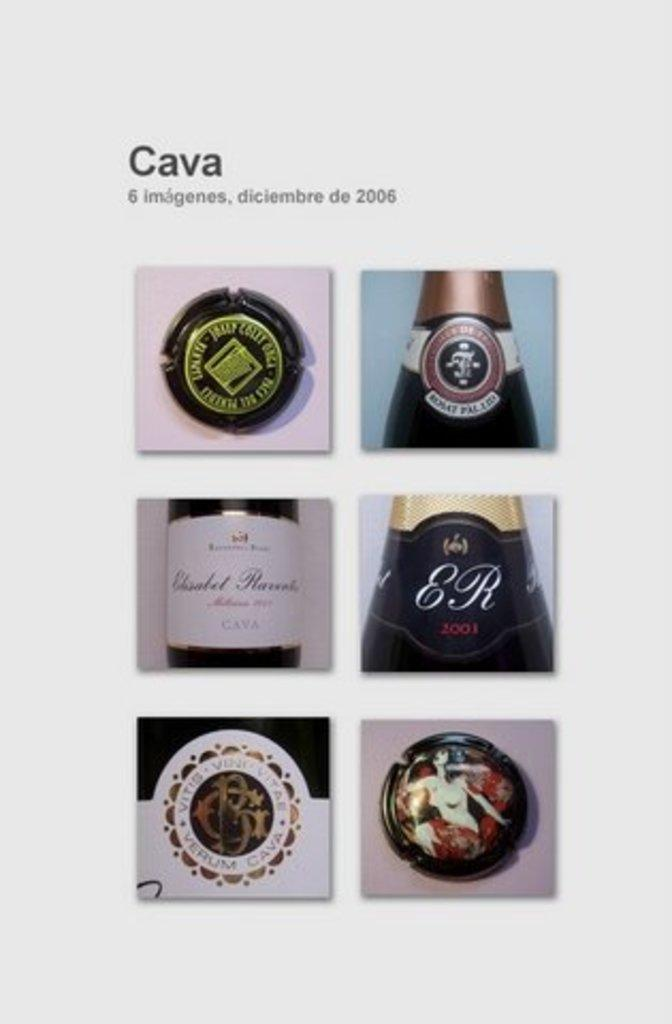<image>
Summarize the visual content of the image. A picture of wine bottles is appearing in cava images. 